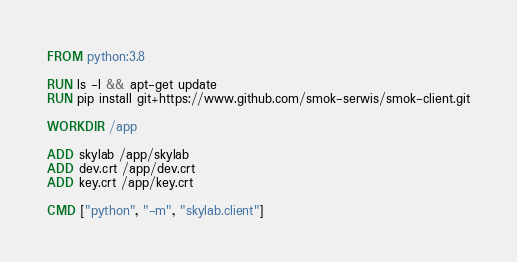Convert code to text. <code><loc_0><loc_0><loc_500><loc_500><_Dockerfile_>FROM python:3.8

RUN ls -l && apt-get update
RUN pip install git+https://www.github.com/smok-serwis/smok-client.git

WORKDIR /app

ADD skylab /app/skylab
ADD dev.crt /app/dev.crt
ADD key.crt /app/key.crt

CMD ["python", "-m", "skylab.client"]
</code> 